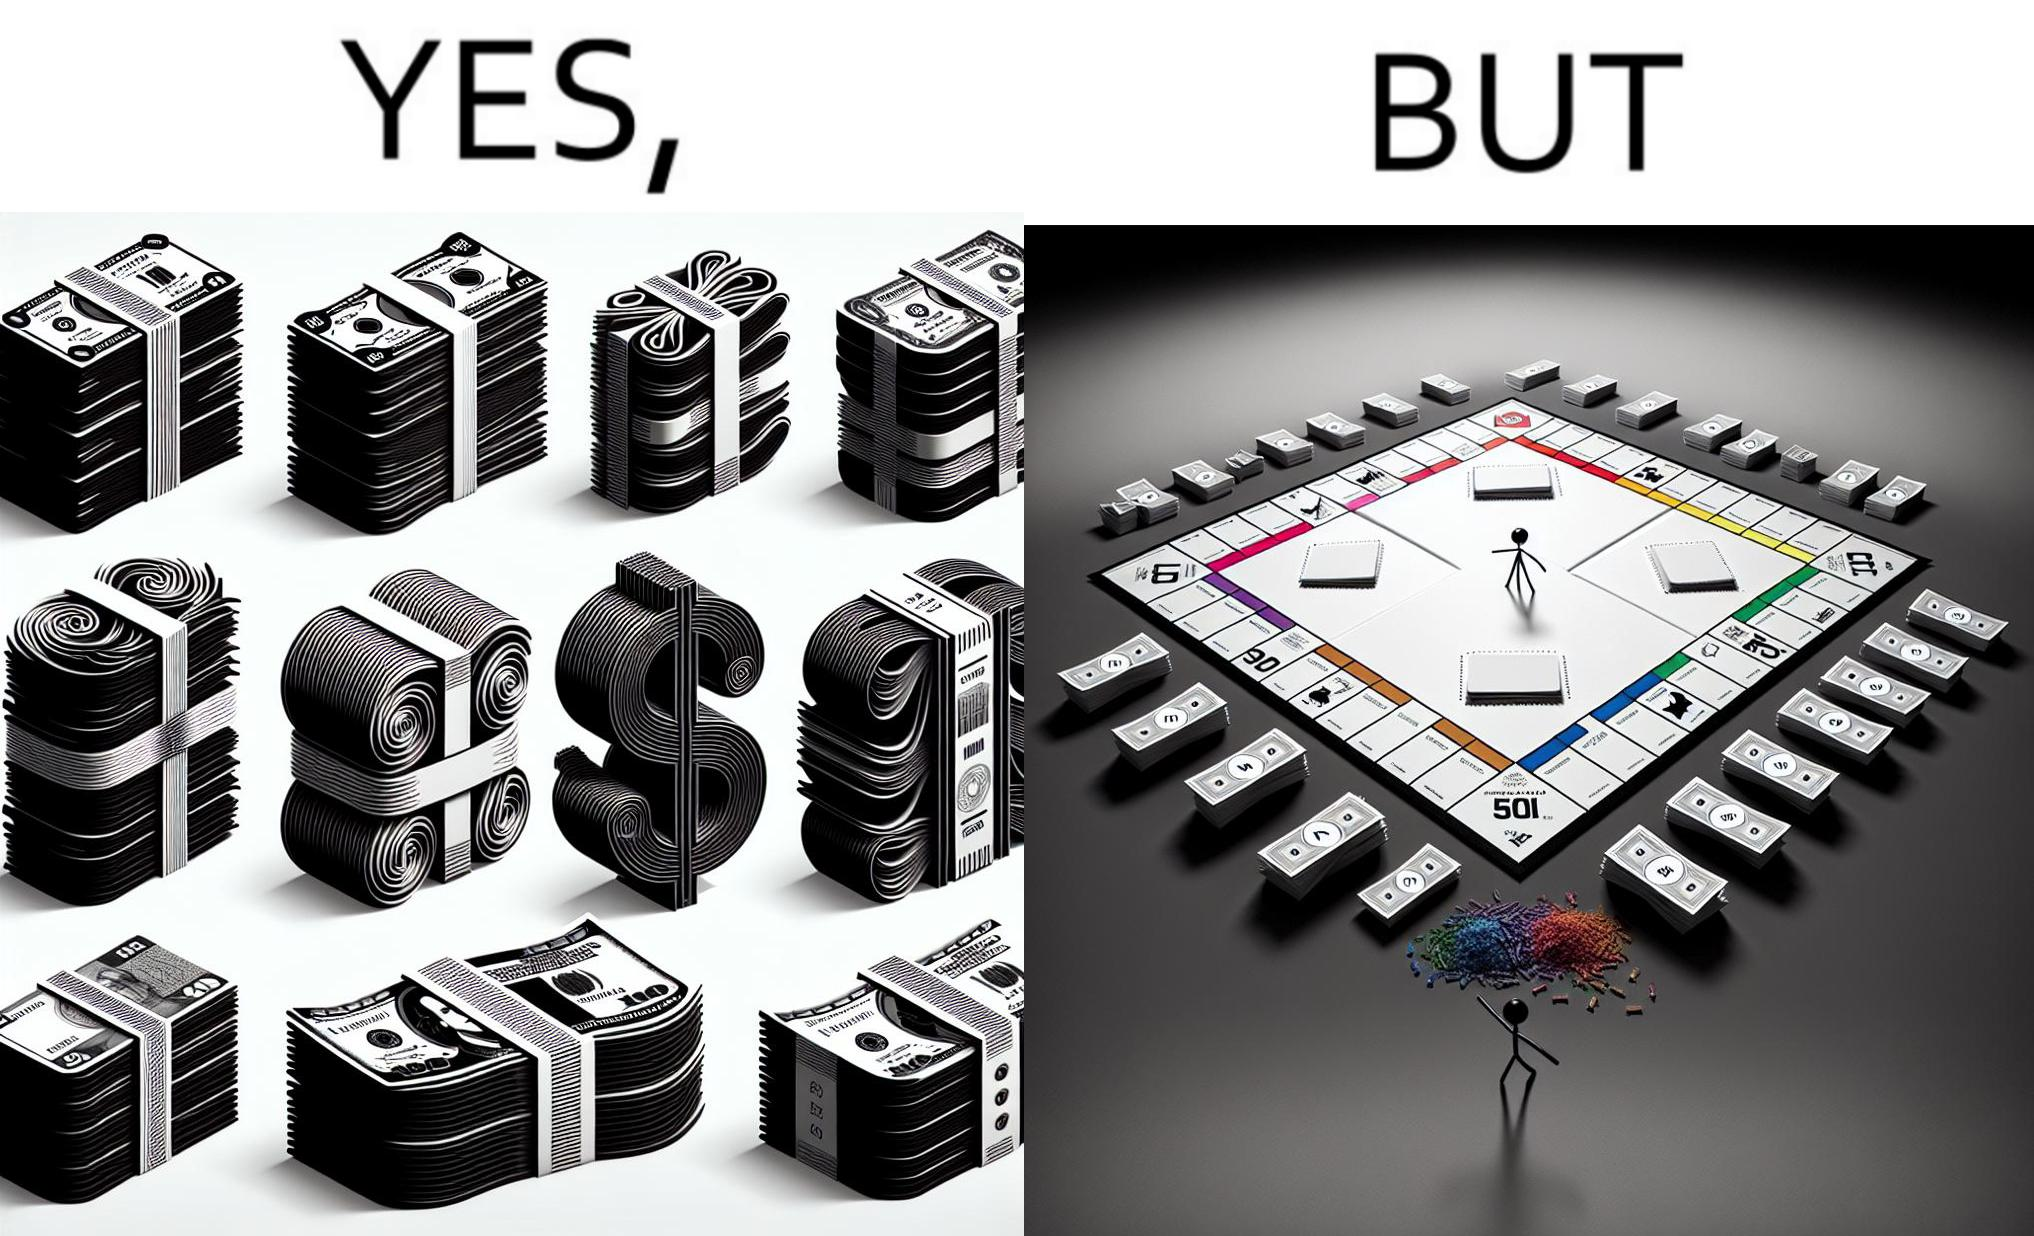Provide a description of this image. The image is ironic, because there are many different color currency notes' bundles but they are just as a currency in the game of monopoly and they have no real value 